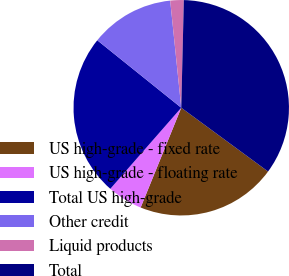<chart> <loc_0><loc_0><loc_500><loc_500><pie_chart><fcel>US high-grade - fixed rate<fcel>US high-grade - floating rate<fcel>Total US high-grade<fcel>Other credit<fcel>Liquid products<fcel>Total<nl><fcel>21.07%<fcel>5.29%<fcel>24.33%<fcel>12.59%<fcel>2.02%<fcel>34.7%<nl></chart> 